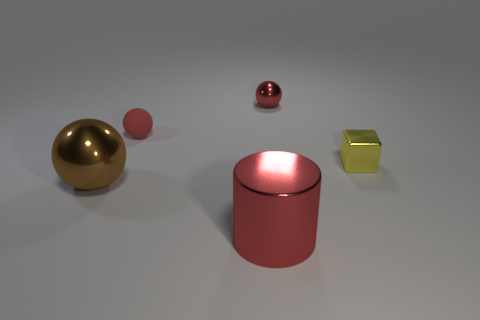What material is the tiny thing that is the same color as the matte sphere?
Keep it short and to the point. Metal. Is there anything else that is the same size as the block?
Keep it short and to the point. Yes. How many red shiny things are behind the metal cube?
Keep it short and to the point. 1. There is a small metallic object left of the yellow metallic object; does it have the same color as the object that is in front of the large ball?
Your response must be concise. Yes. There is another metallic thing that is the same shape as the big brown thing; what is its color?
Offer a terse response. Red. Is there anything else that has the same shape as the tiny red metal thing?
Make the answer very short. Yes. Do the red metal thing behind the tiny metallic cube and the small thing that is on the left side of the small red metallic object have the same shape?
Your response must be concise. Yes. There is a brown metallic sphere; is its size the same as the red shiny object in front of the small red metal object?
Provide a succinct answer. Yes. Are there more green matte blocks than brown balls?
Offer a very short reply. No. Does the red thing in front of the tiny metal cube have the same material as the small sphere to the left of the large red metallic thing?
Your answer should be compact. No. 